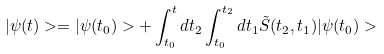Convert formula to latex. <formula><loc_0><loc_0><loc_500><loc_500>| \psi ( t ) > = | \psi ( t _ { 0 } ) > + \int _ { t _ { 0 } } ^ { t } d t _ { 2 } \int _ { t _ { 0 } } ^ { t _ { 2 } } d t _ { 1 } \tilde { S } ( t _ { 2 } , t _ { 1 } ) | \psi ( t _ { 0 } ) ></formula> 